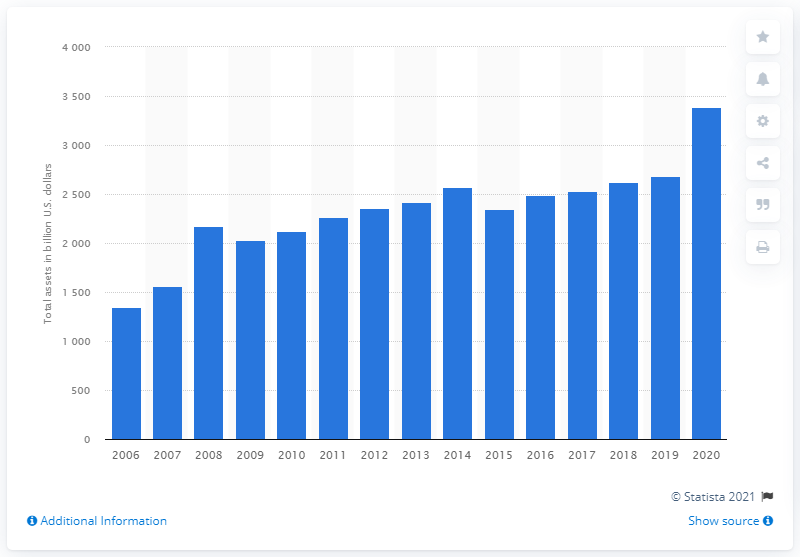Outline some significant characteristics in this image. In 2006, the total assets of JPMorgan Chase were 1,351.52. The total assets of JPMorgan Chase in 2020 were 3386.07 dollars. 